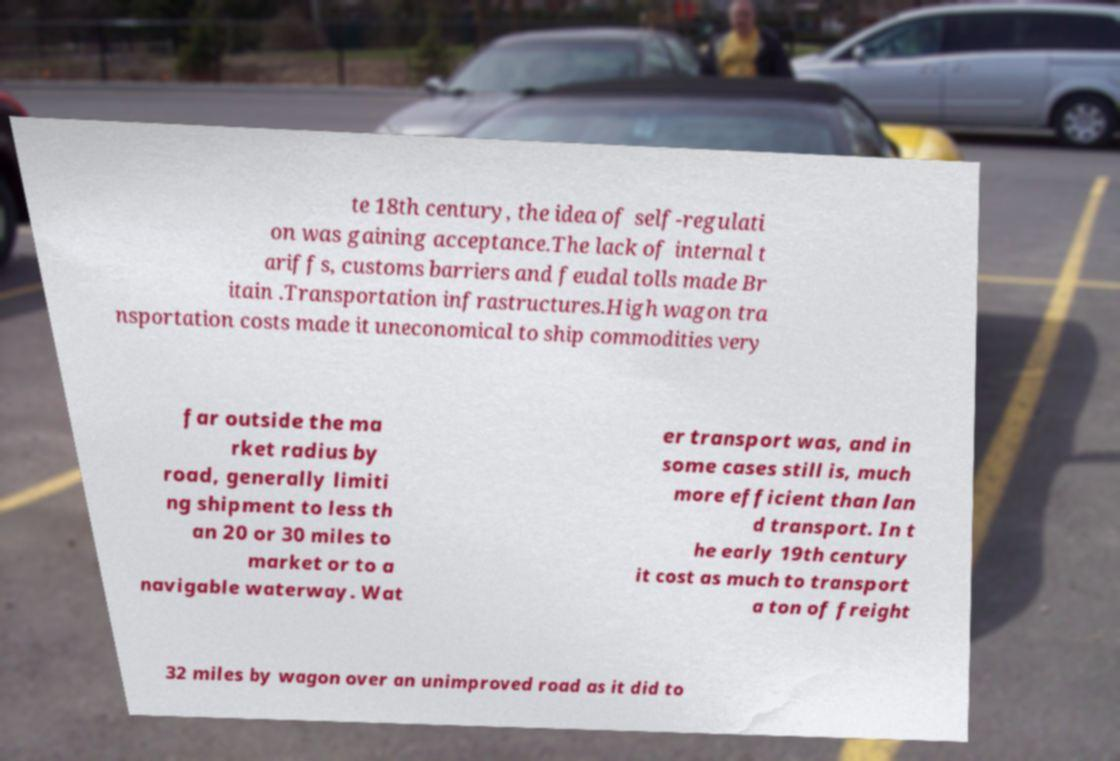Could you extract and type out the text from this image? te 18th century, the idea of self-regulati on was gaining acceptance.The lack of internal t ariffs, customs barriers and feudal tolls made Br itain .Transportation infrastructures.High wagon tra nsportation costs made it uneconomical to ship commodities very far outside the ma rket radius by road, generally limiti ng shipment to less th an 20 or 30 miles to market or to a navigable waterway. Wat er transport was, and in some cases still is, much more efficient than lan d transport. In t he early 19th century it cost as much to transport a ton of freight 32 miles by wagon over an unimproved road as it did to 